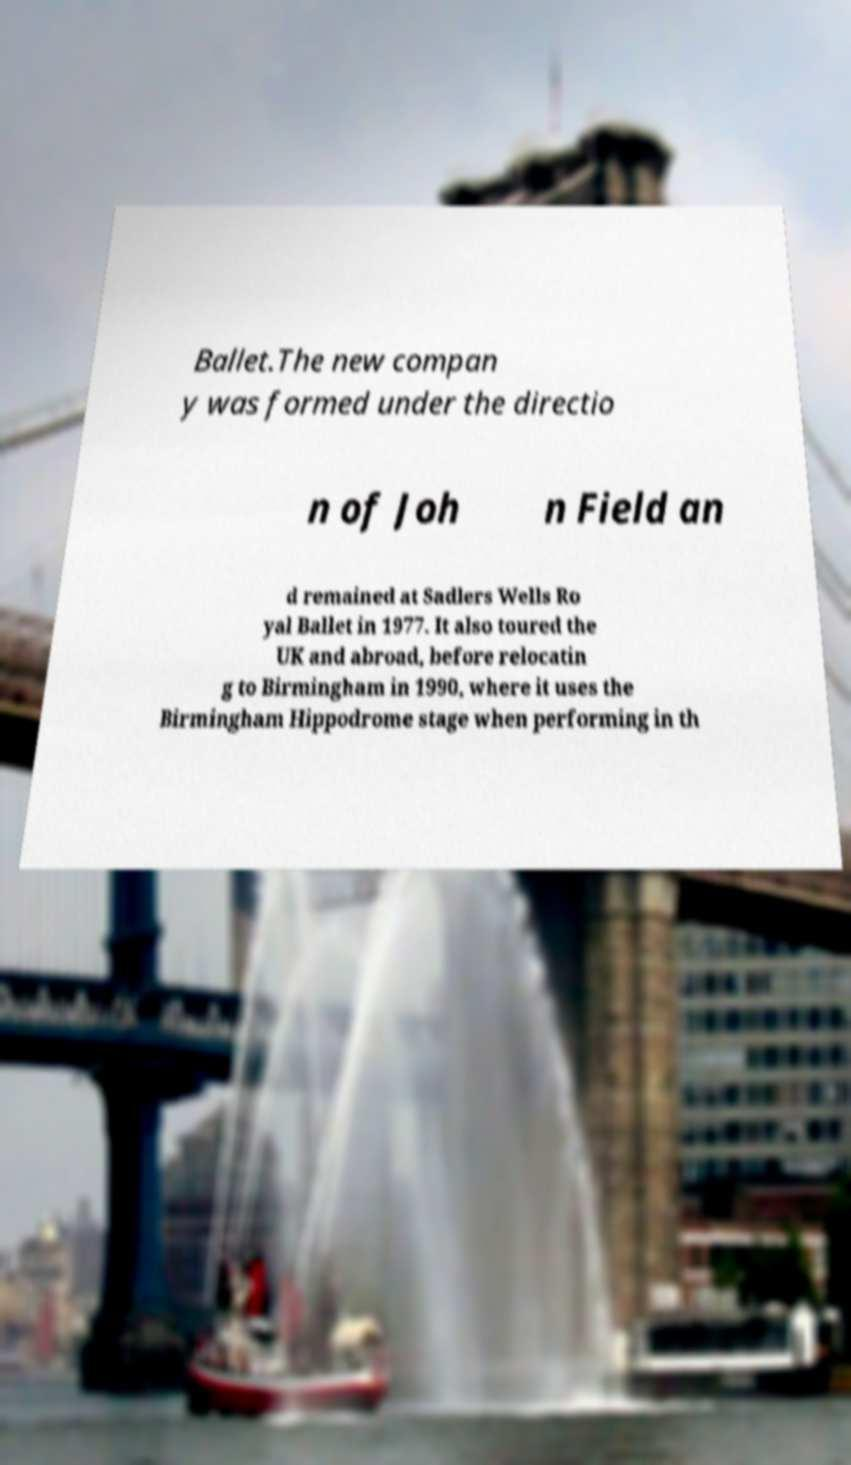Could you assist in decoding the text presented in this image and type it out clearly? Ballet.The new compan y was formed under the directio n of Joh n Field an d remained at Sadlers Wells Ro yal Ballet in 1977. It also toured the UK and abroad, before relocatin g to Birmingham in 1990, where it uses the Birmingham Hippodrome stage when performing in th 